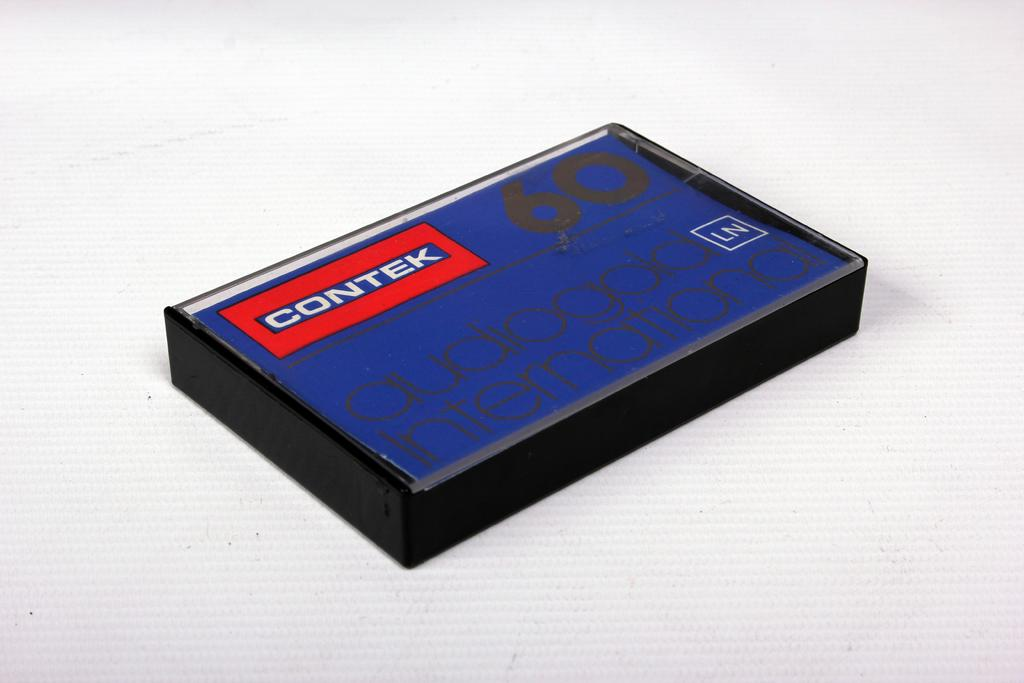<image>
Share a concise interpretation of the image provided. a cassette case labeled 'contek audiogold international' in black 